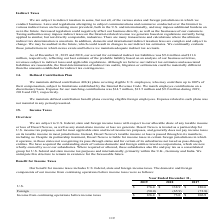According to Godaddy's financial document, What does benefit for income taxes include? U.S. federal, state and foreign income taxes. The document states: "We are subject to U.S. federal, state and foreign income taxes with respect to our allocable share of any taxable income or loss of Desert Newco, as w..." Also, What does the table show? The domestic and foreign components of our income from continuing operations before income taxes. The document states: "des U.S. federal, state and foreign income taxes. The domestic and foreign components of our income from continuing operations before income taxes wer..." Also, Which financial years' information is shown in the table? The document contains multiple relevant values: 2017, 2018, 2019. From the document: "Year Ended December 31, 2019 2018 2017 U.S. $ 176.4 $ 138.9 $ 180.6 Foreign (50.0) (65.9) (73.8) Income from continuing operations before Year Ended D..." Also, can you calculate: What is the average U.S. income from continuing operations before income taxes for 2018 and 2019? To answer this question, I need to perform calculations using the financial data. The calculation is: (176.4+138.9)/2, which equals 157.65. This is based on the information: "Year Ended December 31, 2019 2018 2017 U.S. $ 176.4 $ 138.9 $ 180.6 Foreign (50.0) (65.9) (73.8) Income from continuing operations before income taxes Ended December 31, 2019 2018 2017 U.S. $ 176.4 $ ..." The key data points involved are: 138.9, 176.4. Also, can you calculate: What is the average U.S. income from continuing operations before income taxes for 2017 and 2018? To answer this question, I need to perform calculations using the financial data. The calculation is: (138.9+180.6)/2, which equals 159.75. This is based on the information: "Ended December 31, 2019 2018 2017 U.S. $ 176.4 $ 138.9 $ 180.6 Foreign (50.0) (65.9) (73.8) Income from continuing operations before income taxes $ 126.4 ecember 31, 2019 2018 2017 U.S. $ 176.4 $ 138...." The key data points involved are: 138.9, 180.6. Also, can you calculate: What is the change in the average U.S. income from continuing operations before income taxes between 2017-2018 and 2018-2019?  To answer this question, I need to perform calculations using the financial data. The calculation is: [(176.4+138.9)/2] - [(138.9+180.6)/2], which equals -2.1. This is based on the information: "Year Ended December 31, 2019 2018 2017 U.S. $ 176.4 $ 138.9 $ 180.6 Foreign (50.0) (65.9) (73.8) Income from continuing operations before income taxes Ended December 31, 2019 2018 2017 U.S. $ 176.4 $ ..." The key data points involved are: 138.9, 176.4, 180.6. 